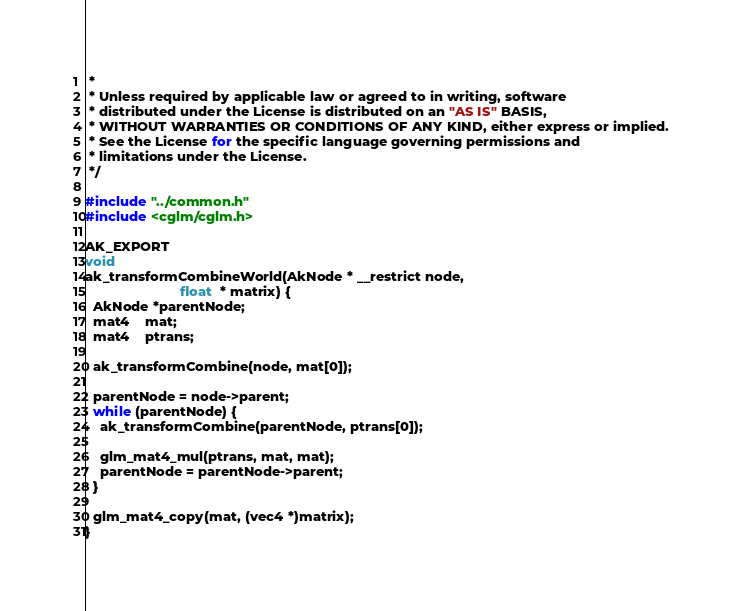Convert code to text. <code><loc_0><loc_0><loc_500><loc_500><_C_> *
 * Unless required by applicable law or agreed to in writing, software
 * distributed under the License is distributed on an "AS IS" BASIS,
 * WITHOUT WARRANTIES OR CONDITIONS OF ANY KIND, either express or implied.
 * See the License for the specific language governing permissions and
 * limitations under the License.
 */

#include "../common.h"
#include <cglm/cglm.h>

AK_EXPORT
void
ak_transformCombineWorld(AkNode * __restrict node,
                         float  * matrix) {
  AkNode *parentNode;
  mat4    mat;
  mat4    ptrans;

  ak_transformCombine(node, mat[0]);

  parentNode = node->parent;
  while (parentNode) {
    ak_transformCombine(parentNode, ptrans[0]);

    glm_mat4_mul(ptrans, mat, mat);
    parentNode = parentNode->parent;
  }

  glm_mat4_copy(mat, (vec4 *)matrix);
}
</code> 